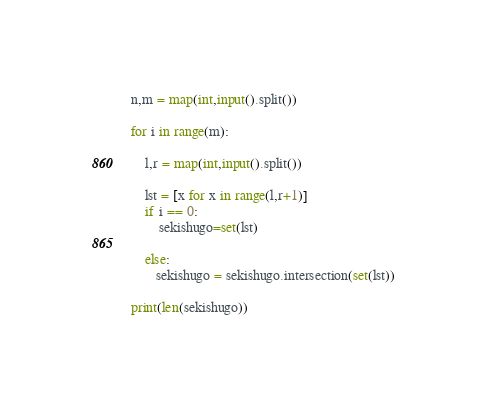<code> <loc_0><loc_0><loc_500><loc_500><_Python_>n,m = map(int,input().split())

for i in range(m):
    
    l,r = map(int,input().split())

    lst = [x for x in range(l,r+1)]
    if i == 0:
        sekishugo=set(lst)

    else:
       sekishugo = sekishugo.intersection(set(lst))

print(len(sekishugo))
</code> 